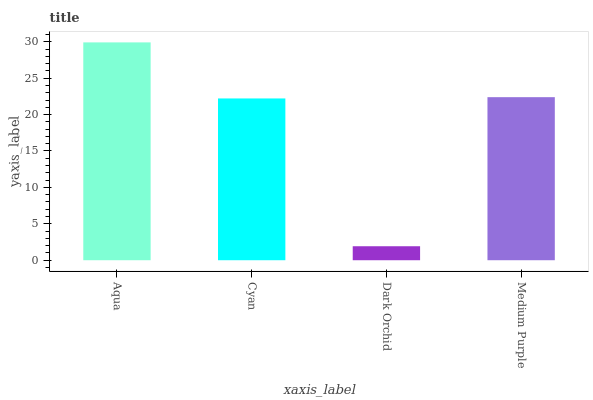Is Dark Orchid the minimum?
Answer yes or no. Yes. Is Aqua the maximum?
Answer yes or no. Yes. Is Cyan the minimum?
Answer yes or no. No. Is Cyan the maximum?
Answer yes or no. No. Is Aqua greater than Cyan?
Answer yes or no. Yes. Is Cyan less than Aqua?
Answer yes or no. Yes. Is Cyan greater than Aqua?
Answer yes or no. No. Is Aqua less than Cyan?
Answer yes or no. No. Is Medium Purple the high median?
Answer yes or no. Yes. Is Cyan the low median?
Answer yes or no. Yes. Is Cyan the high median?
Answer yes or no. No. Is Aqua the low median?
Answer yes or no. No. 